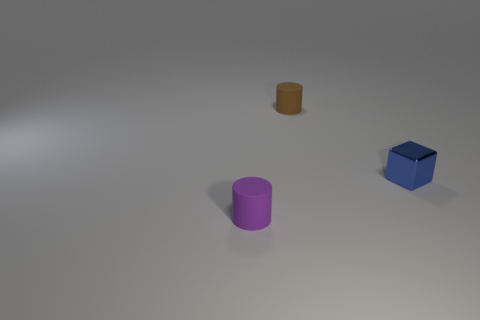Can you describe the colors and shapes of the objects in the image? In the image, there is a small blue cube, a purple cylinder, and a tiny brown cylinder. The cube has a distinct sharp-edged shape typical of cubes, while both cylinders have curved surfaces and circular bases, with the brown one being smaller in size than the purple one. 